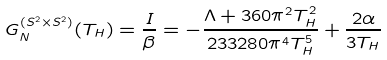<formula> <loc_0><loc_0><loc_500><loc_500>G _ { N } ^ { ( S ^ { 2 } \times S ^ { 2 } ) } ( T _ { H } ) = \frac { I } { \beta } = - \frac { \Lambda + 3 6 0 \pi ^ { 2 } T _ { H } ^ { 2 } } { 2 3 3 2 8 0 \pi ^ { 4 } T _ { H } ^ { 5 } } + \frac { 2 \alpha } { 3 T _ { H } }</formula> 